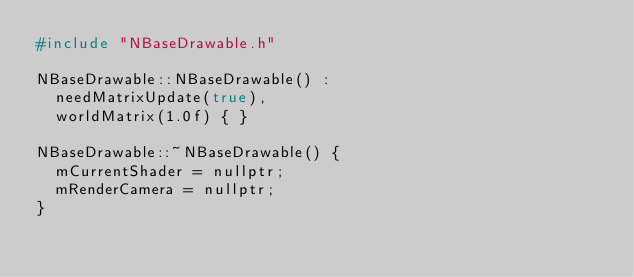Convert code to text. <code><loc_0><loc_0><loc_500><loc_500><_C++_>#include "NBaseDrawable.h"

NBaseDrawable::NBaseDrawable() :
	needMatrixUpdate(true),
	worldMatrix(1.0f) { }

NBaseDrawable::~NBaseDrawable() {
	mCurrentShader = nullptr;
	mRenderCamera = nullptr;
}
</code> 